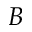<formula> <loc_0><loc_0><loc_500><loc_500>B</formula> 